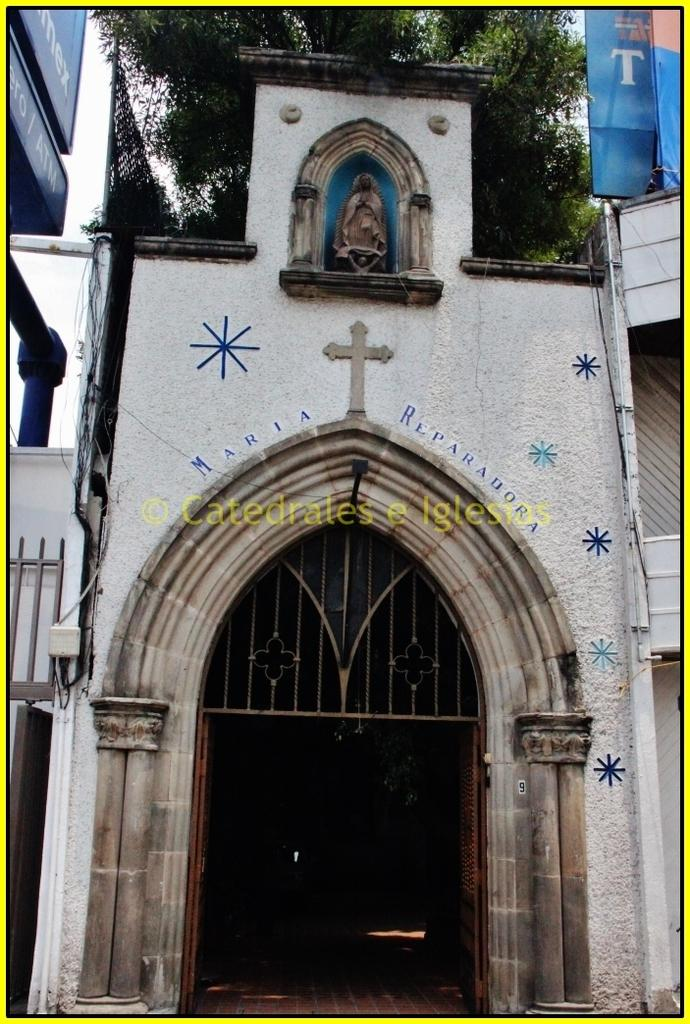What type of building is shown in the image? The image shows the front view of a church. What can be seen in the background of the image? There are trees visible at the top of the image. Are there any decorations or additional elements present in the image? Yes, banners are present at the top of the image. How many chairs are visible in the image? There are no chairs present in the image. What time of day is depicted in the image? The time of day cannot be determined from the image. 